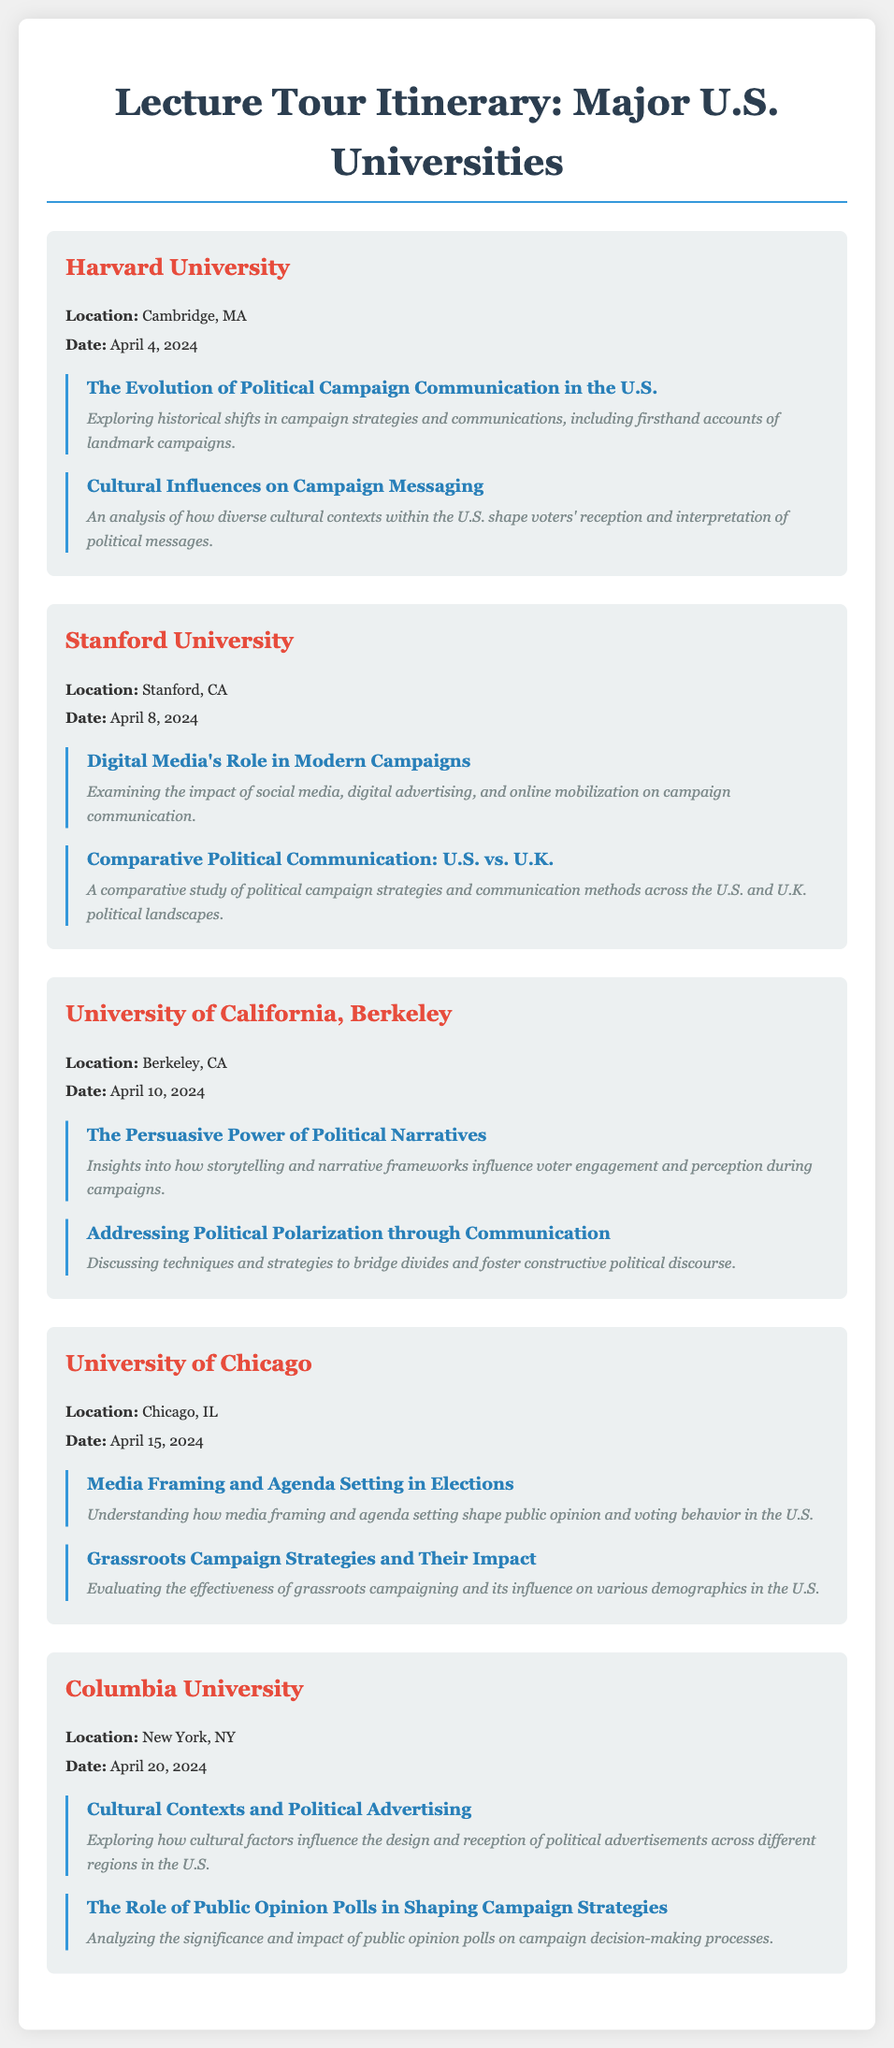What is the date of the lecture at Harvard University? The date of the lecture at Harvard University is mentioned in the document as April 4, 2024.
Answer: April 4, 2024 What presentation topic is addressed at Stanford University? The document lists two presentation topics for Stanford University, one of which is "Digital Media's Role in Modern Campaigns."
Answer: Digital Media's Role in Modern Campaigns Which university will host a lecture on political narratives? The lecture on political narratives is scheduled at the University of California, Berkeley, according to the document.
Answer: University of California, Berkeley How many main topics are covered at Columbia University? The document outlines two main topics for Columbia University, indicating the quantity of topics discussed.
Answer: Two What city is the University of Chicago located in? The document states that the University of Chicago is located in Chicago, IL.
Answer: Chicago, IL What is a key focus of the presentation on April 10, 2024? The presentation on that date focuses on "The Persuasive Power of Political Narratives," as mentioned in the document.
Answer: The Persuasive Power of Political Narratives Which university is the last stop on the lecture tour? The document presents Columbia University as the last listed university in the itinerary.
Answer: Columbia University What unique aspect of American culture is addressed in the lecture topics? The document discusses the influence of diverse cultural contexts on political messaging and advertising across the U.S.
Answer: Diverse cultural contexts 